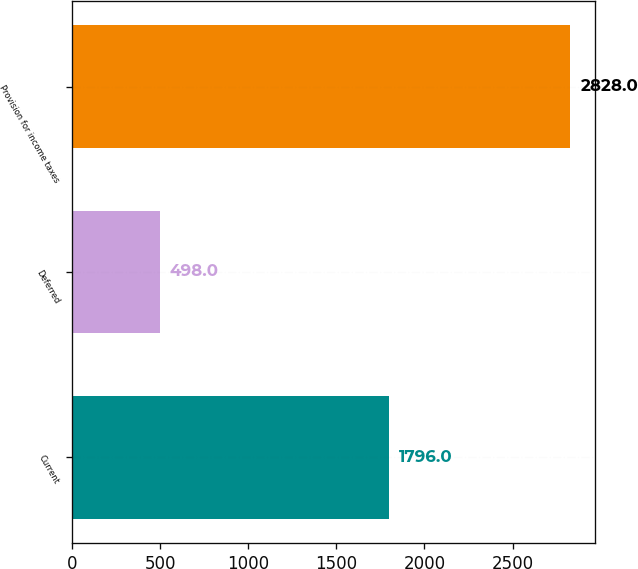Convert chart to OTSL. <chart><loc_0><loc_0><loc_500><loc_500><bar_chart><fcel>Current<fcel>Deferred<fcel>Provision for income taxes<nl><fcel>1796<fcel>498<fcel>2828<nl></chart> 